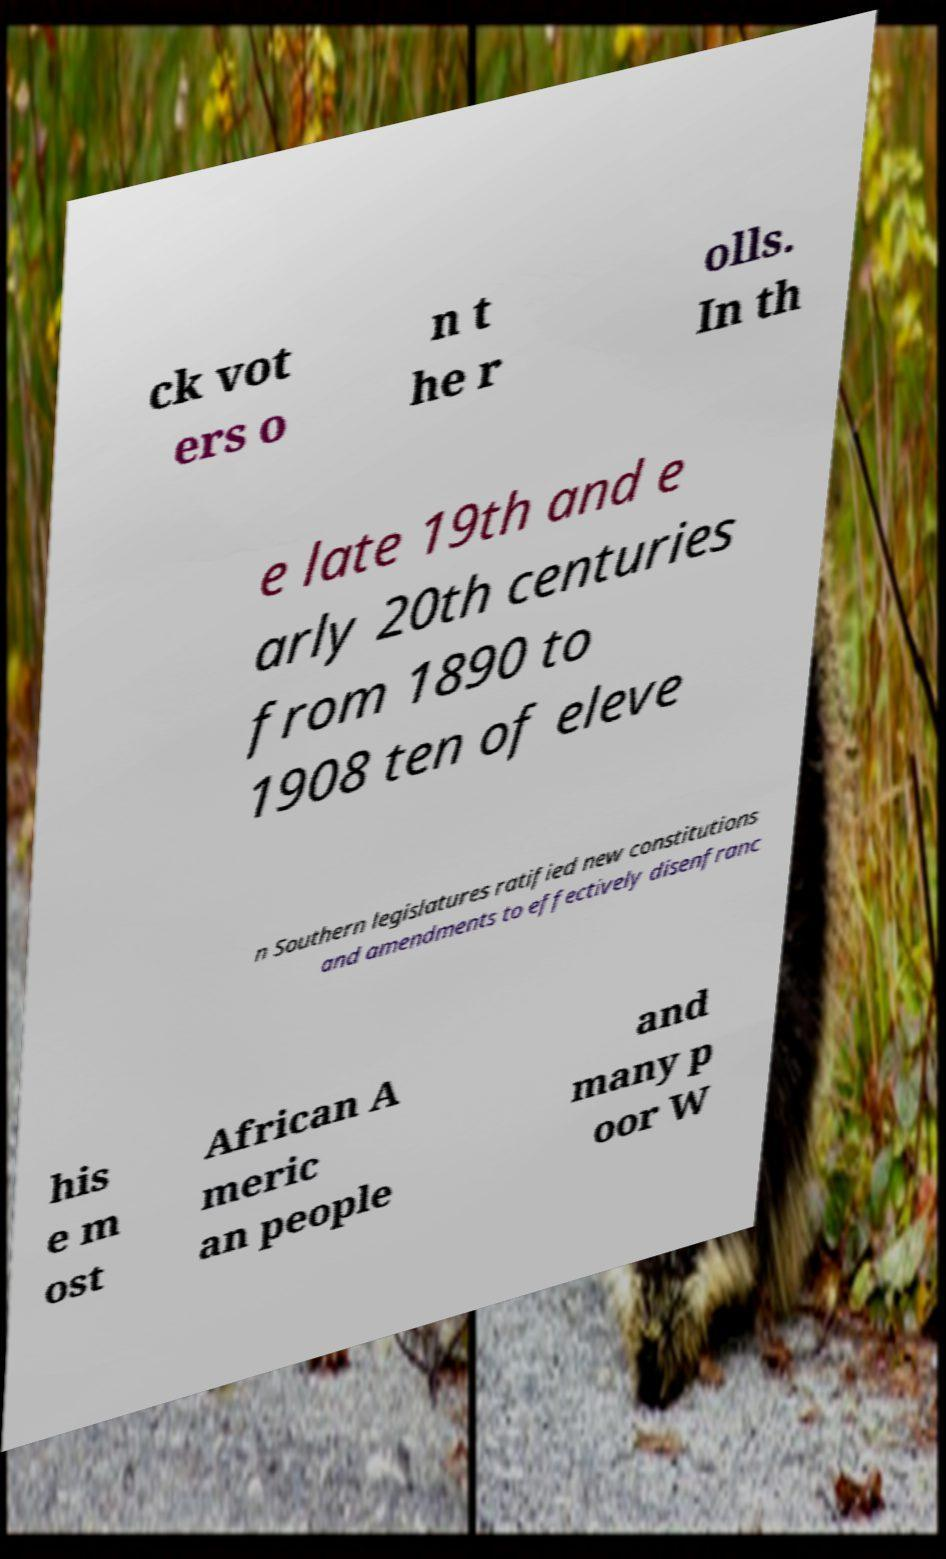Can you accurately transcribe the text from the provided image for me? ck vot ers o n t he r olls. In th e late 19th and e arly 20th centuries from 1890 to 1908 ten of eleve n Southern legislatures ratified new constitutions and amendments to effectively disenfranc his e m ost African A meric an people and many p oor W 